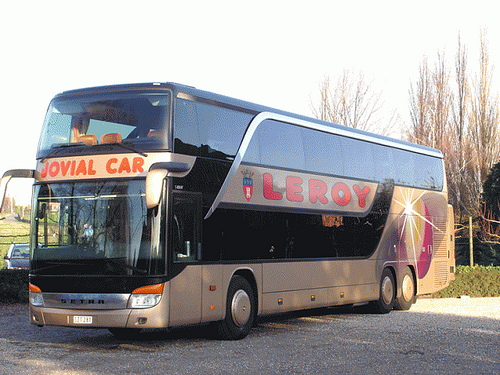<image>Where is this bus going? It is uncertain where the bus is going. Where is this bus going? I don't know where this bus is going. It could be going on a tour, home, to a station, north, nowhere, away, somewhere, or to Houston. 